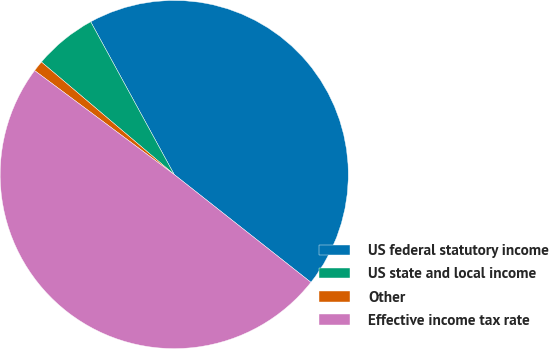<chart> <loc_0><loc_0><loc_500><loc_500><pie_chart><fcel>US federal statutory income<fcel>US state and local income<fcel>Other<fcel>Effective income tax rate<nl><fcel>43.59%<fcel>5.85%<fcel>1.0%<fcel>49.56%<nl></chart> 